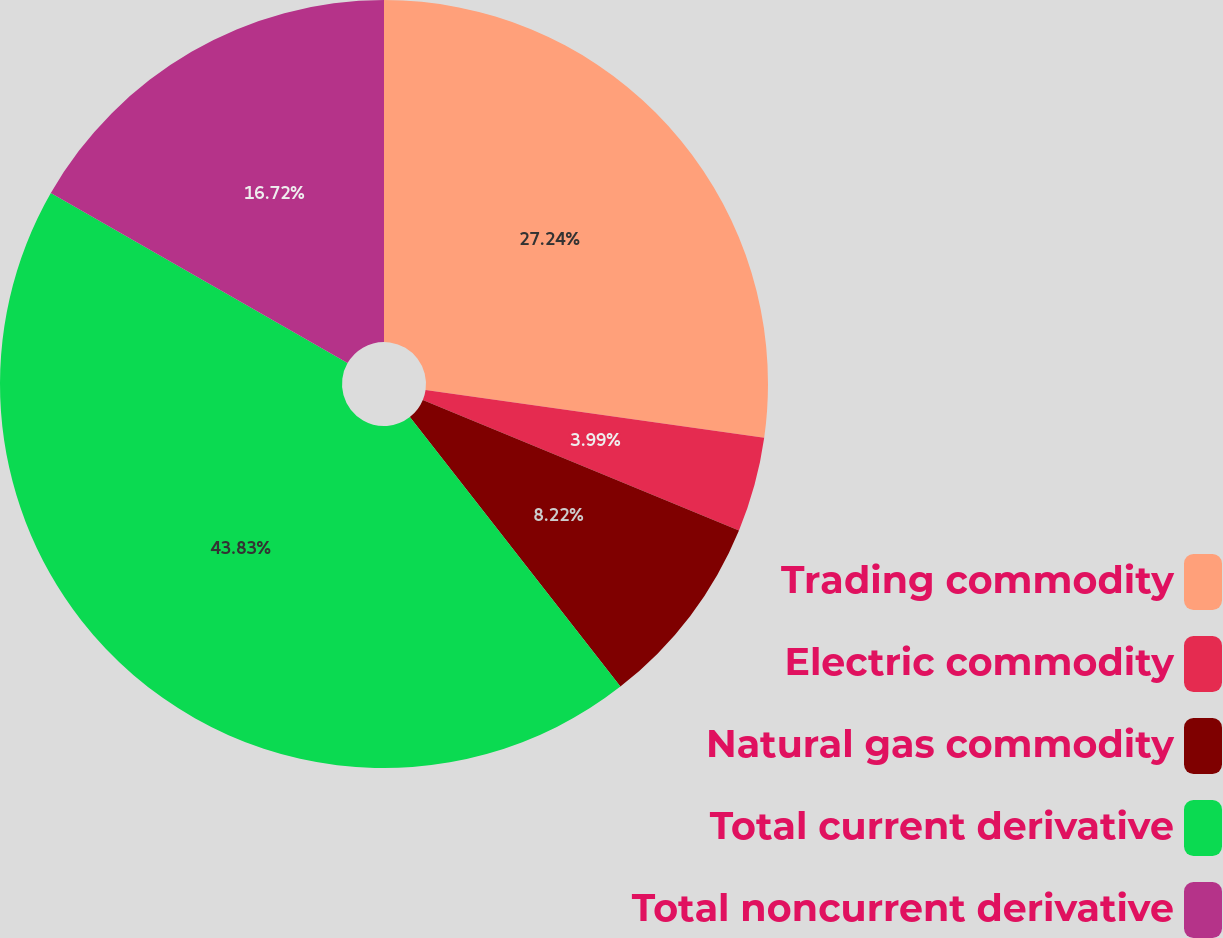<chart> <loc_0><loc_0><loc_500><loc_500><pie_chart><fcel>Trading commodity<fcel>Electric commodity<fcel>Natural gas commodity<fcel>Total current derivative<fcel>Total noncurrent derivative<nl><fcel>27.24%<fcel>3.99%<fcel>8.22%<fcel>43.84%<fcel>16.72%<nl></chart> 